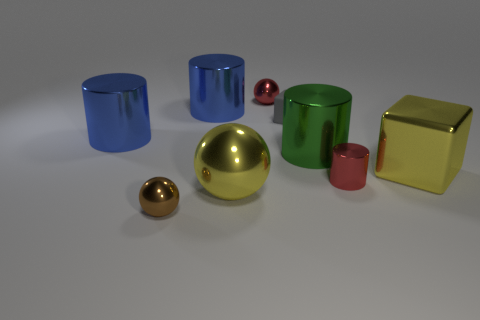Add 1 large yellow shiny spheres. How many objects exist? 10 Subtract all cylinders. How many objects are left? 5 Add 5 brown shiny spheres. How many brown shiny spheres are left? 6 Add 4 small metallic things. How many small metallic things exist? 7 Subtract 0 cyan cubes. How many objects are left? 9 Subtract all tiny cylinders. Subtract all large metal cubes. How many objects are left? 7 